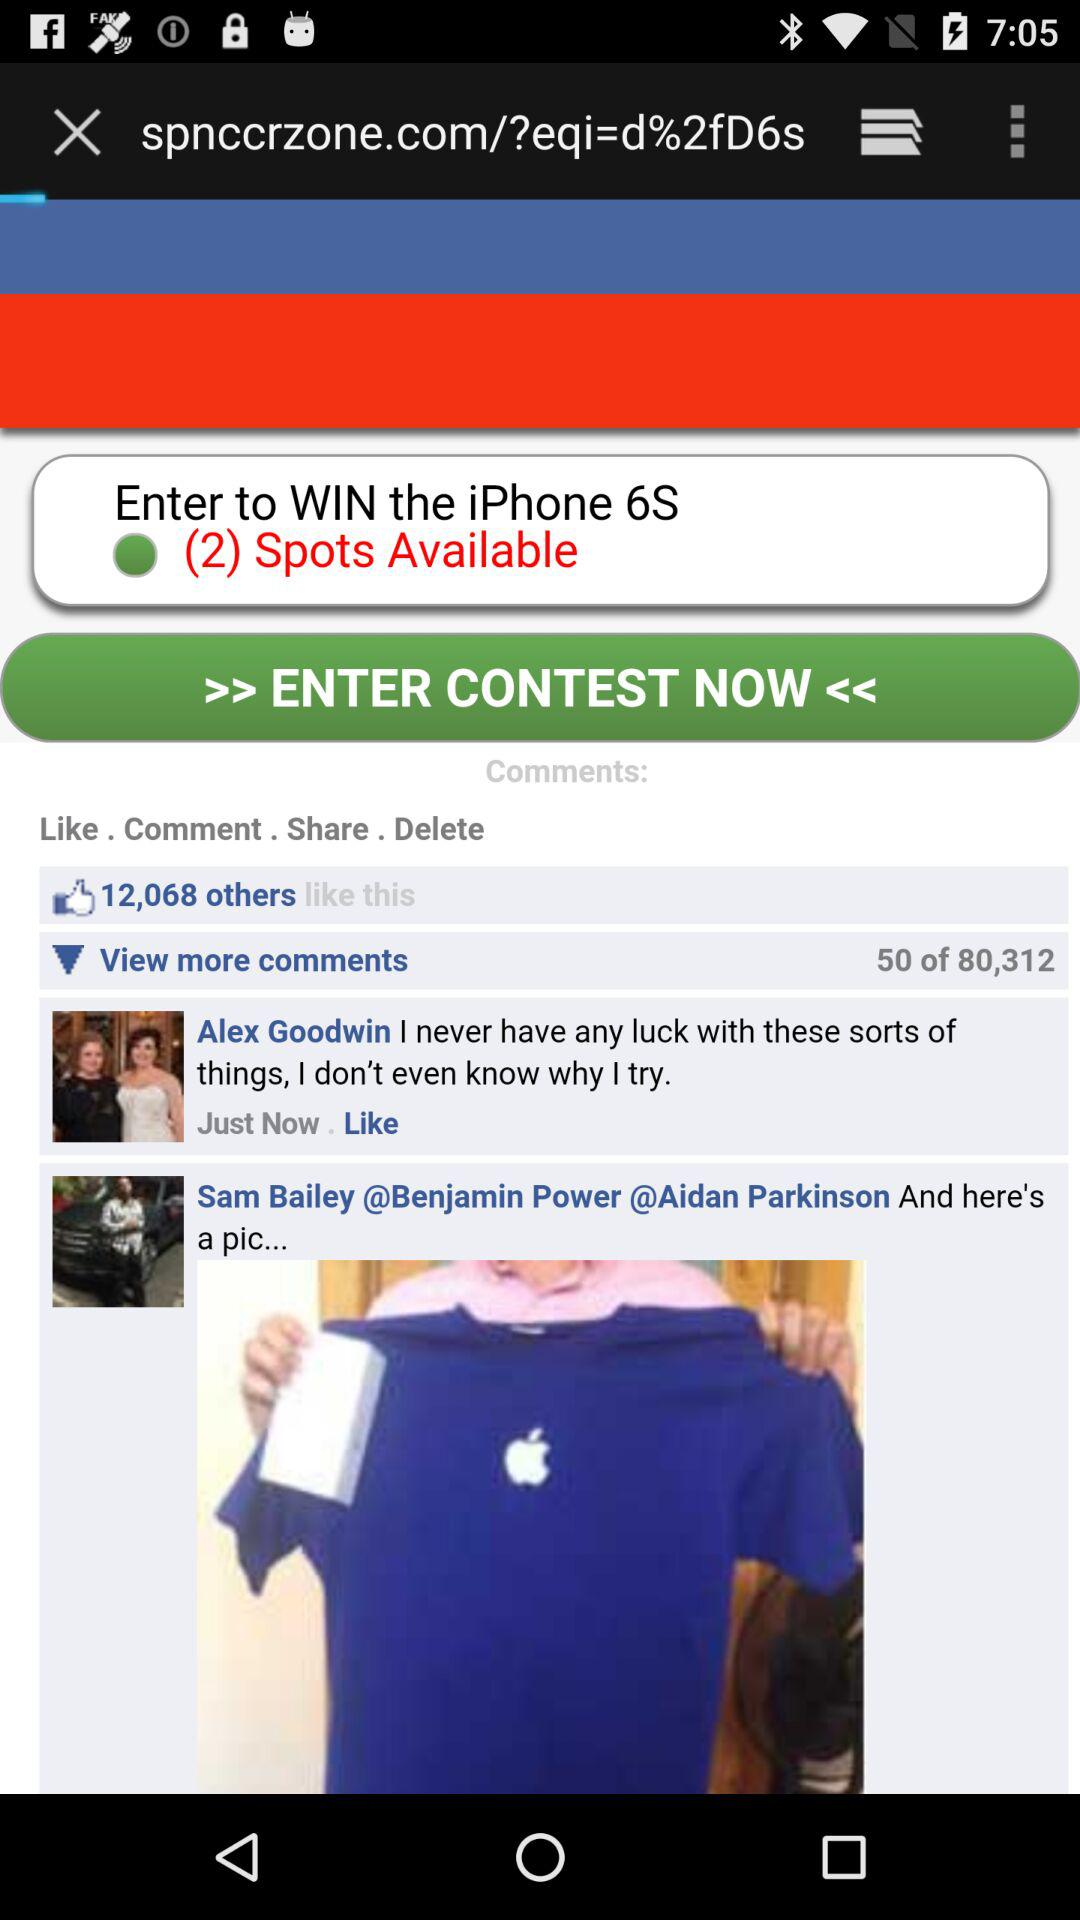How many likes are there? There are 12,068 likes. 